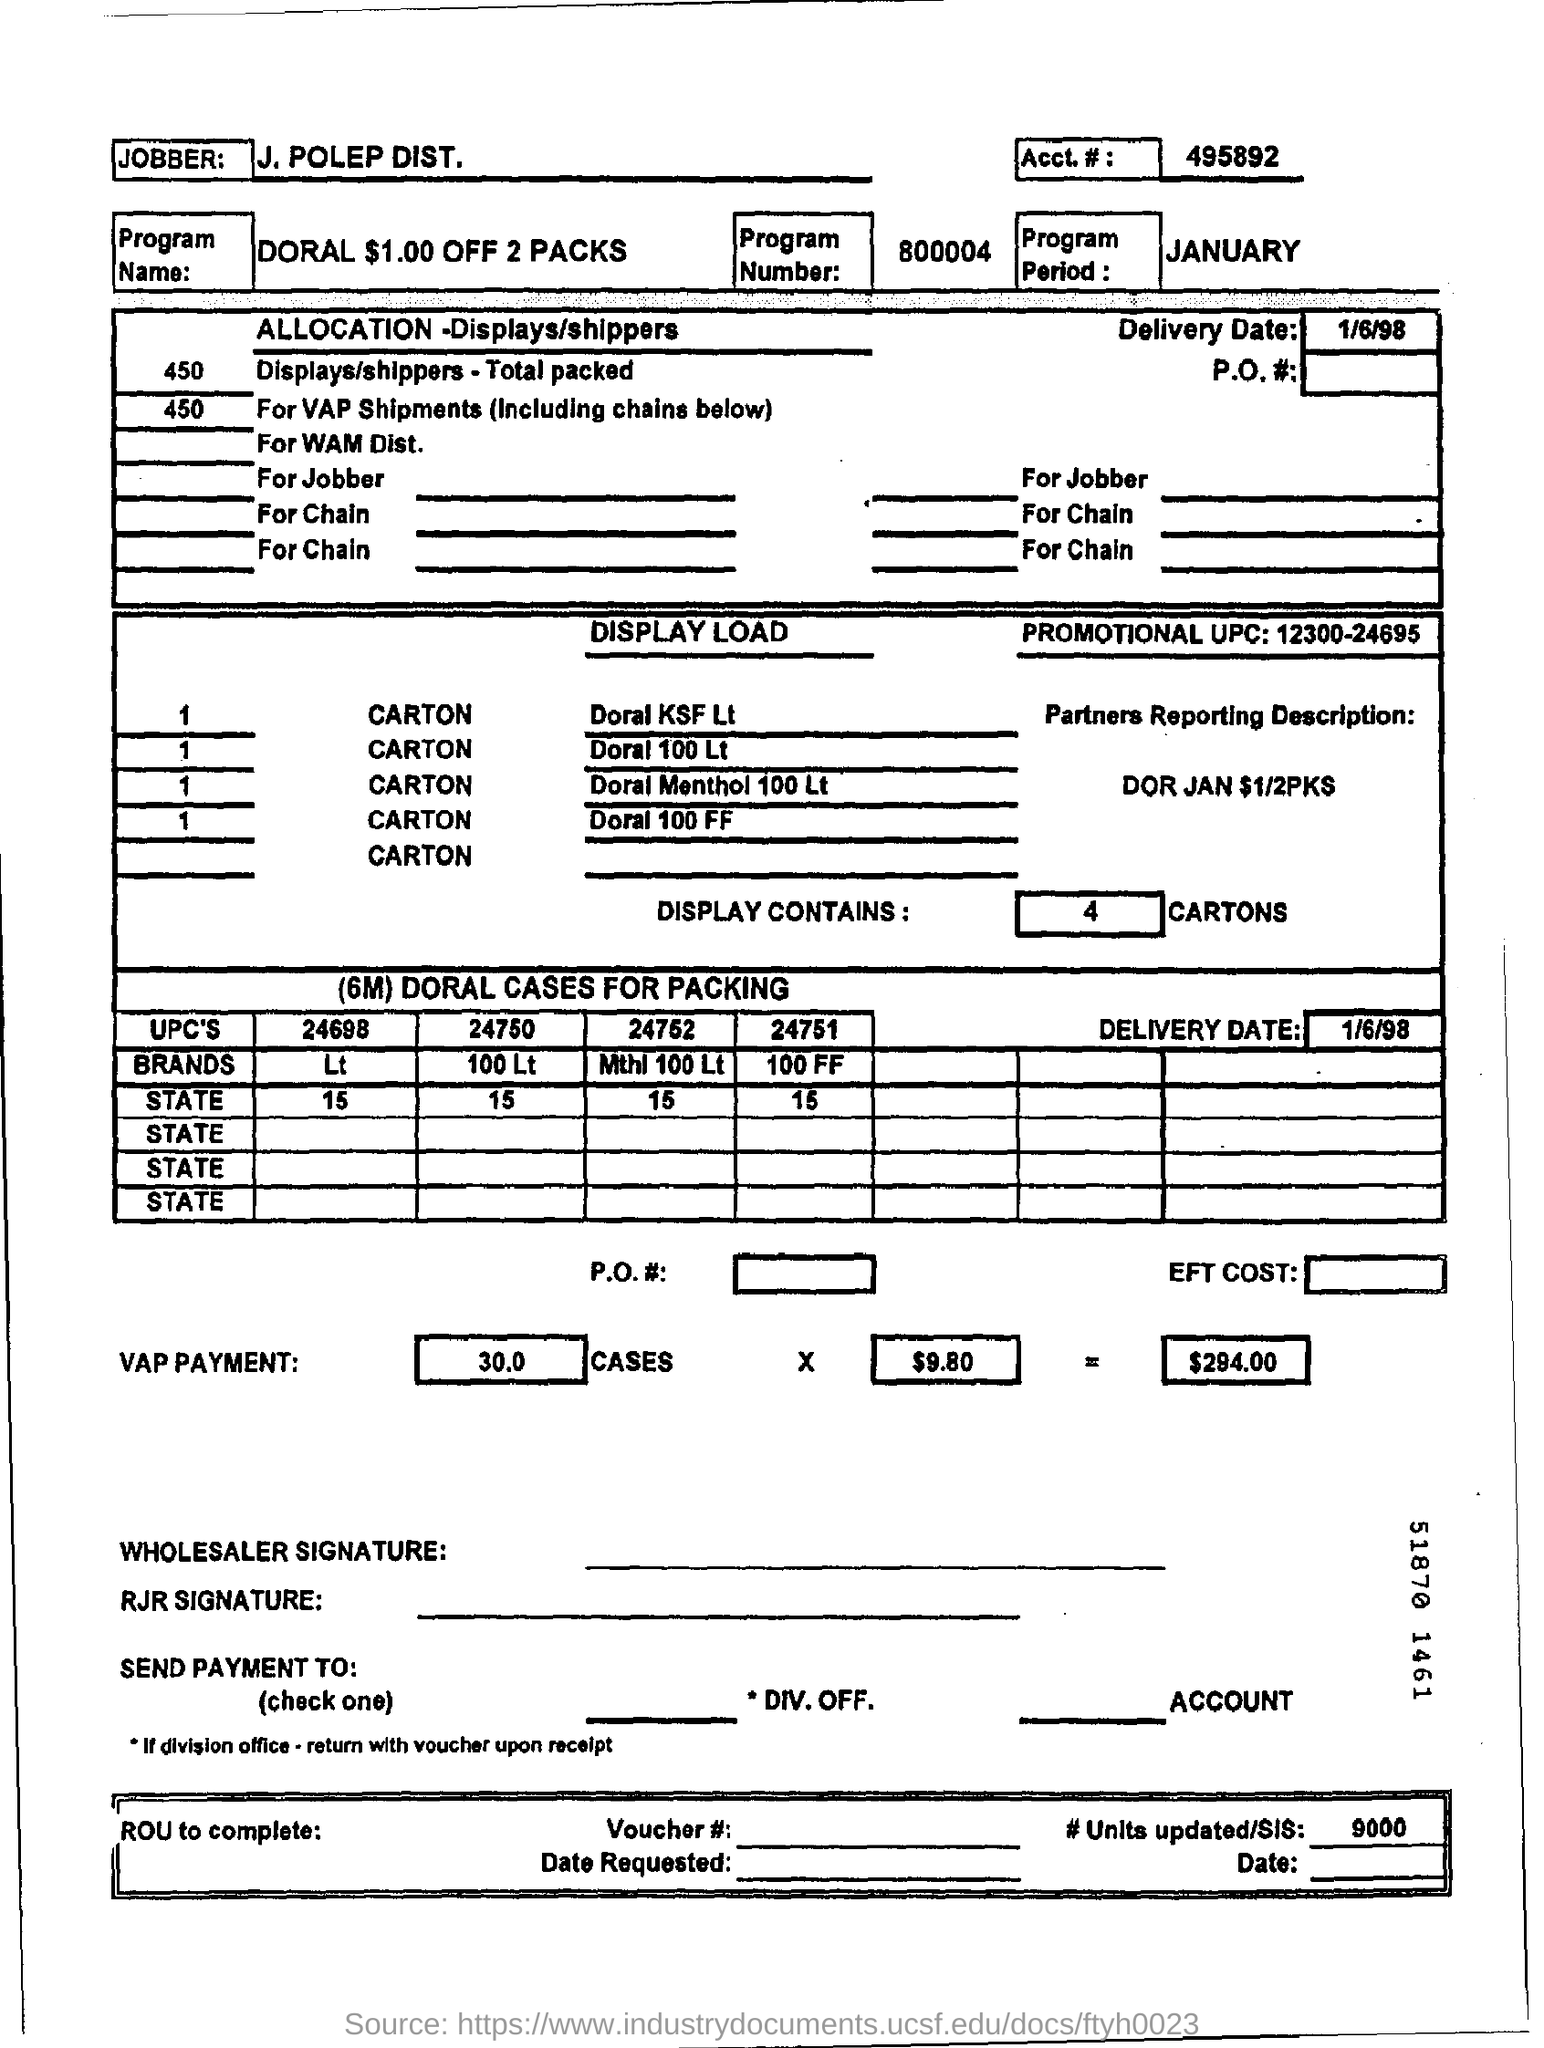List a handful of essential elements in this visual. The program name is Doral, and it offers a discount of $1.00 on any purchase of two packs. The program period is from JANUARY. The total VAP payment is $294.00. The account number is 495892... What is the program number?" is a question that is asking for information. The program number is 800004. 